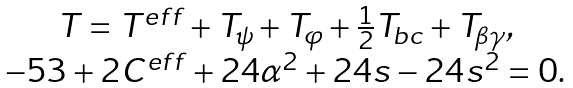Convert formula to latex. <formula><loc_0><loc_0><loc_500><loc_500>\begin{array} { c } T = T ^ { e f f } + T _ { \psi } + T _ { \varphi } + \frac { 1 } { 2 } T _ { b c } + T _ { \beta \gamma } , \\ - 5 3 + 2 C ^ { e f f } + 2 4 \alpha ^ { 2 } + 2 4 s - 2 4 s ^ { 2 } = 0 . \end{array}</formula> 